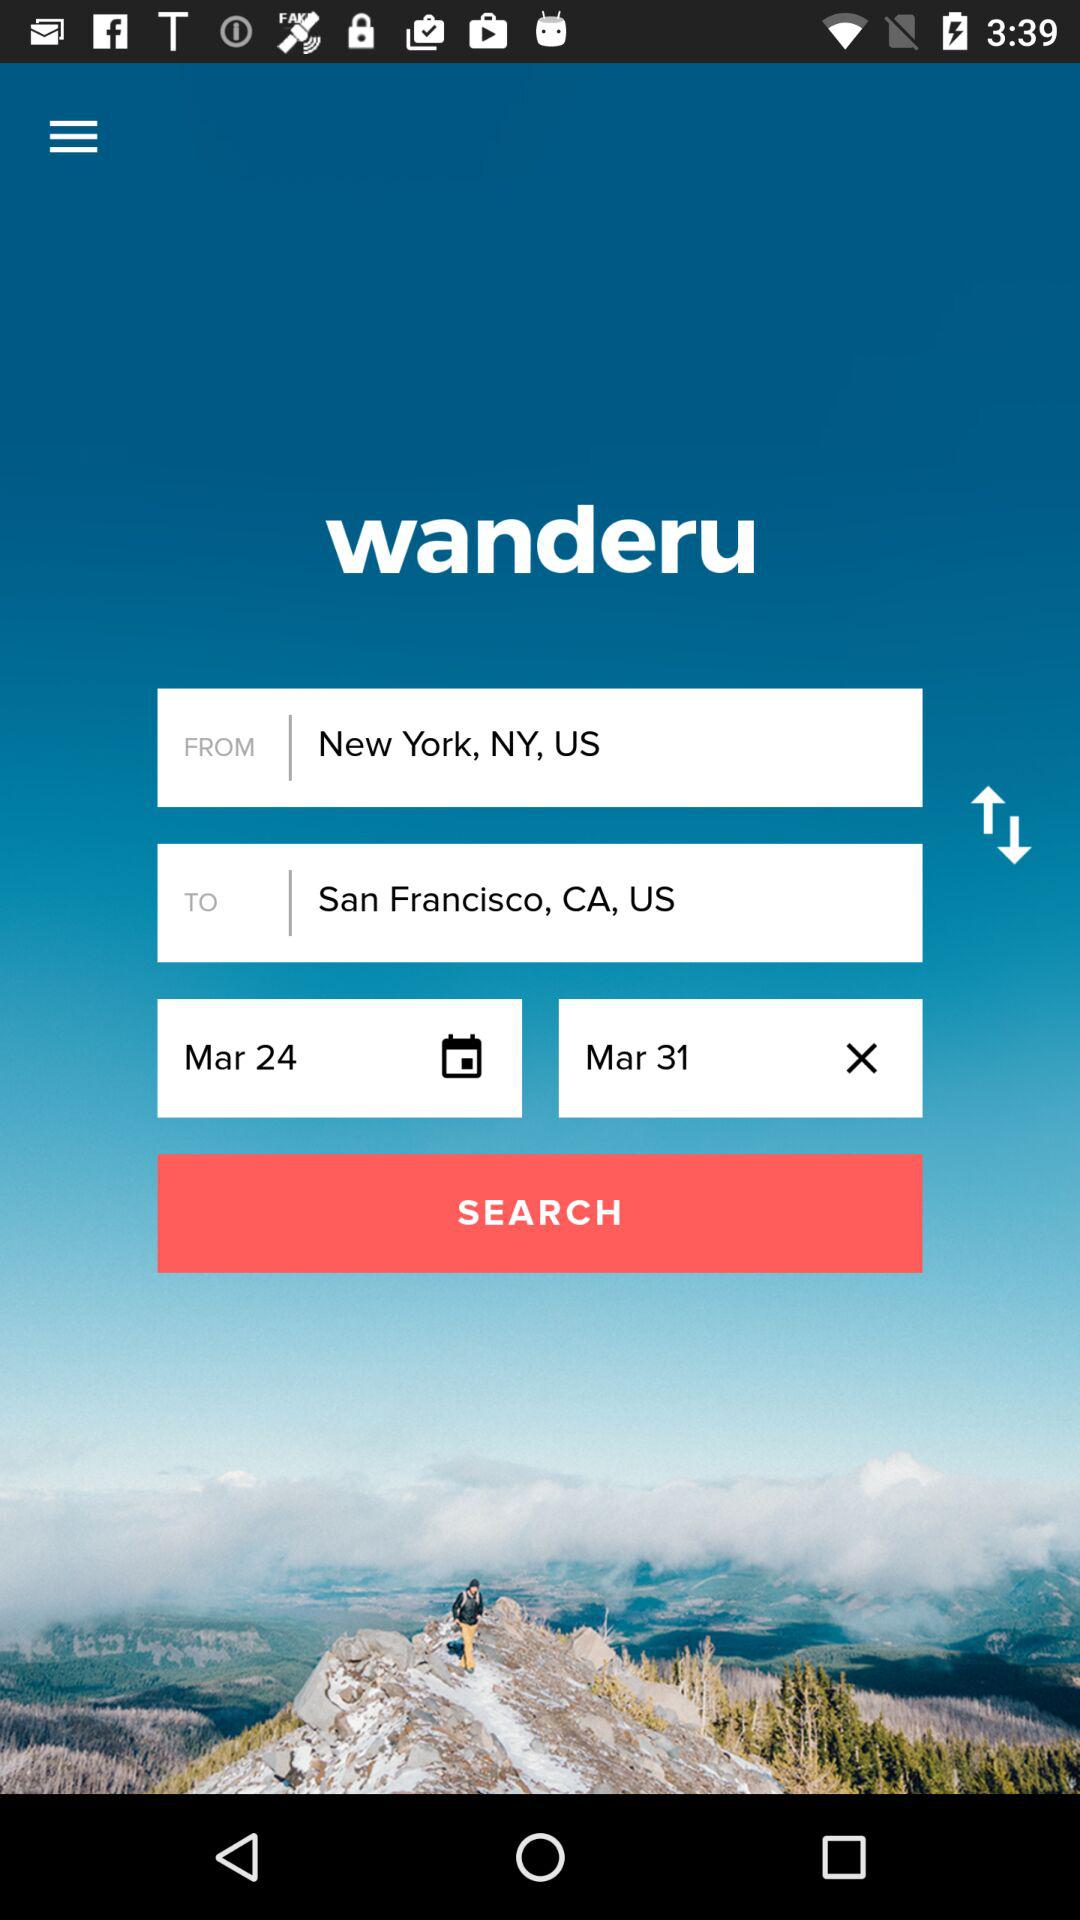What is the flight destination? The flight destination is San Francisco, CA, US. 